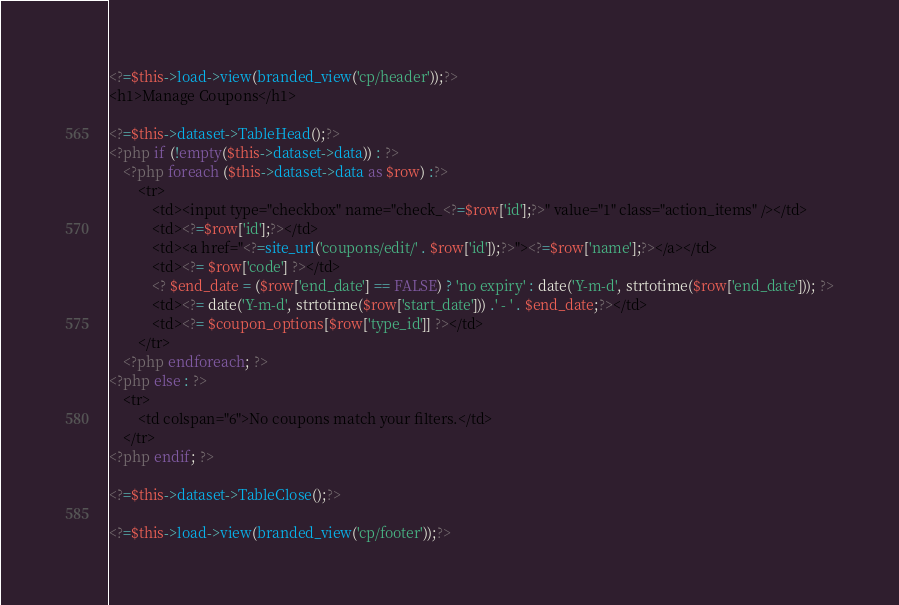<code> <loc_0><loc_0><loc_500><loc_500><_PHP_><?=$this->load->view(branded_view('cp/header'));?>
<h1>Manage Coupons</h1>

<?=$this->dataset->TableHead();?>
<?php if (!empty($this->dataset->data)) : ?>
	<?php foreach ($this->dataset->data as $row) :?>
		<tr>
			<td><input type="checkbox" name="check_<?=$row['id'];?>" value="1" class="action_items" /></td>
			<td><?=$row['id'];?></td>
			<td><a href="<?=site_url('coupons/edit/' . $row['id']);?>"><?=$row['name'];?></a></td>
			<td><?= $row['code'] ?></td>
			<? $end_date = ($row['end_date'] == FALSE) ? 'no expiry' : date('Y-m-d', strtotime($row['end_date'])); ?>
			<td><?= date('Y-m-d', strtotime($row['start_date'])) .' - ' . $end_date;?></td>
			<td><?= $coupon_options[$row['type_id']] ?></td>
		</tr>
	<?php endforeach; ?>
<?php else : ?>
	<tr>
		<td colspan="6">No coupons match your filters.</td>
	</tr>
<?php endif; ?>

<?=$this->dataset->TableClose();?>

<?=$this->load->view(branded_view('cp/footer'));?></code> 